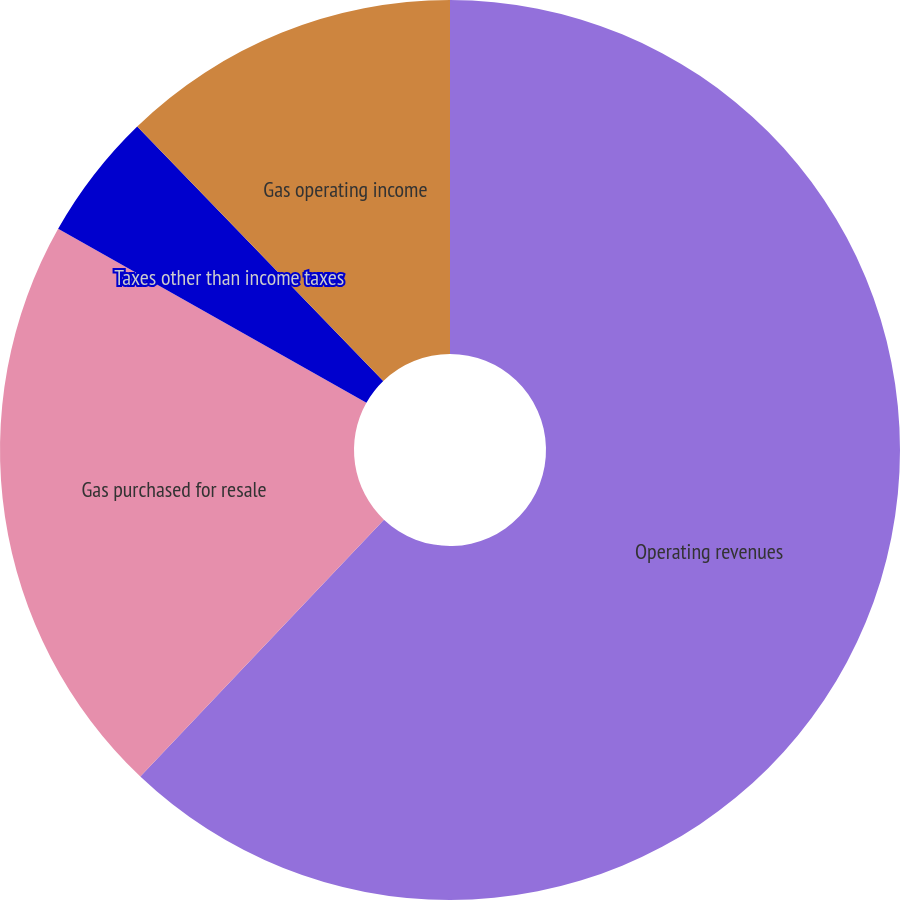Convert chart. <chart><loc_0><loc_0><loc_500><loc_500><pie_chart><fcel>Operating revenues<fcel>Gas purchased for resale<fcel>Taxes other than income taxes<fcel>Gas operating income<nl><fcel>62.08%<fcel>21.1%<fcel>4.59%<fcel>12.23%<nl></chart> 